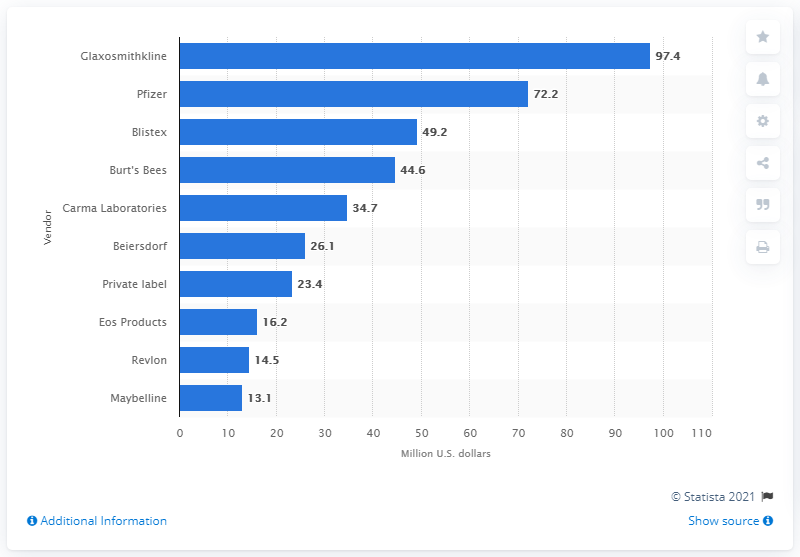List a handful of essential elements in this visual. Glaxosmithkline was the leading vendor of lip balm and cold sore medication in the United States in 2012. 